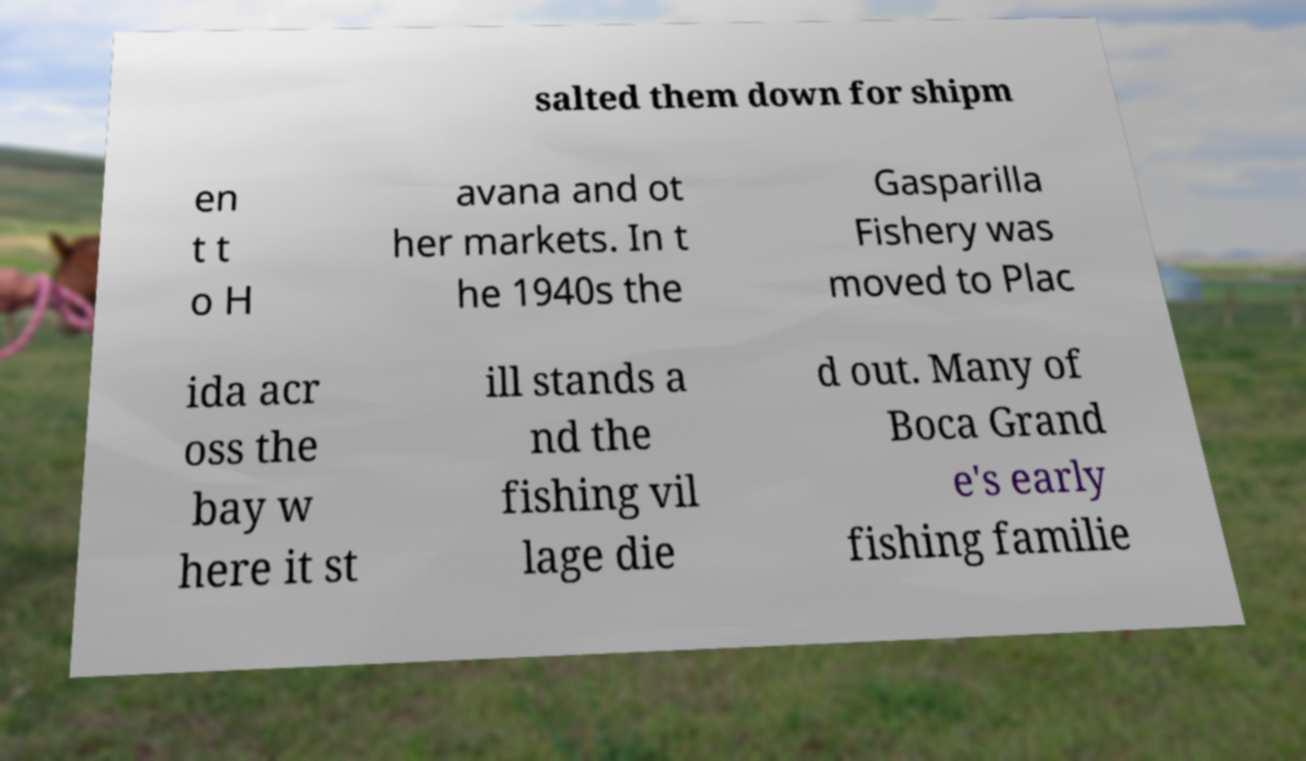What messages or text are displayed in this image? I need them in a readable, typed format. salted them down for shipm en t t o H avana and ot her markets. In t he 1940s the Gasparilla Fishery was moved to Plac ida acr oss the bay w here it st ill stands a nd the fishing vil lage die d out. Many of Boca Grand e's early fishing familie 